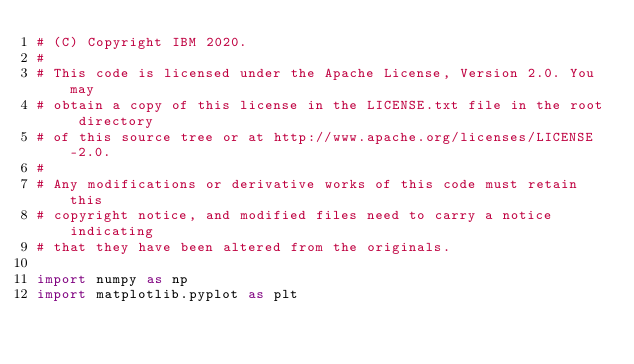Convert code to text. <code><loc_0><loc_0><loc_500><loc_500><_Python_># (C) Copyright IBM 2020.
#
# This code is licensed under the Apache License, Version 2.0. You may
# obtain a copy of this license in the LICENSE.txt file in the root directory
# of this source tree or at http://www.apache.org/licenses/LICENSE-2.0.
#
# Any modifications or derivative works of this code must retain this
# copyright notice, and modified files need to carry a notice indicating
# that they have been altered from the originals.

import numpy as np
import matplotlib.pyplot as plt</code> 